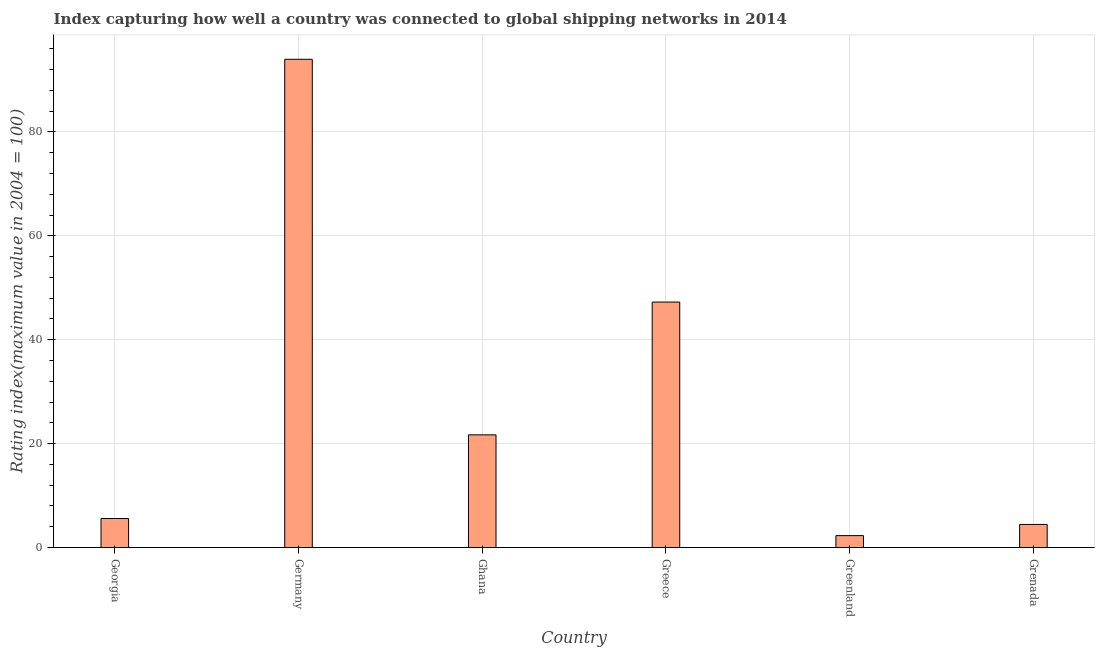Does the graph contain any zero values?
Make the answer very short. No. What is the title of the graph?
Keep it short and to the point. Index capturing how well a country was connected to global shipping networks in 2014. What is the label or title of the X-axis?
Provide a succinct answer. Country. What is the label or title of the Y-axis?
Make the answer very short. Rating index(maximum value in 2004 = 100). What is the liner shipping connectivity index in Germany?
Your response must be concise. 93.98. Across all countries, what is the maximum liner shipping connectivity index?
Provide a succinct answer. 93.98. Across all countries, what is the minimum liner shipping connectivity index?
Give a very brief answer. 2.3. In which country was the liner shipping connectivity index minimum?
Provide a succinct answer. Greenland. What is the sum of the liner shipping connectivity index?
Offer a terse response. 175.24. What is the difference between the liner shipping connectivity index in Greenland and Grenada?
Make the answer very short. -2.15. What is the average liner shipping connectivity index per country?
Keep it short and to the point. 29.21. What is the median liner shipping connectivity index?
Your answer should be very brief. 13.64. What is the ratio of the liner shipping connectivity index in Germany to that in Grenada?
Give a very brief answer. 21.12. Is the liner shipping connectivity index in Ghana less than that in Greece?
Your answer should be compact. Yes. Is the difference between the liner shipping connectivity index in Ghana and Greenland greater than the difference between any two countries?
Keep it short and to the point. No. What is the difference between the highest and the second highest liner shipping connectivity index?
Ensure brevity in your answer.  46.73. Is the sum of the liner shipping connectivity index in Georgia and Ghana greater than the maximum liner shipping connectivity index across all countries?
Ensure brevity in your answer.  No. What is the difference between the highest and the lowest liner shipping connectivity index?
Your answer should be very brief. 91.68. Are all the bars in the graph horizontal?
Your answer should be very brief. No. What is the difference between two consecutive major ticks on the Y-axis?
Give a very brief answer. 20. Are the values on the major ticks of Y-axis written in scientific E-notation?
Provide a succinct answer. No. What is the Rating index(maximum value in 2004 = 100) in Georgia?
Your answer should be very brief. 5.58. What is the Rating index(maximum value in 2004 = 100) of Germany?
Give a very brief answer. 93.98. What is the Rating index(maximum value in 2004 = 100) in Ghana?
Keep it short and to the point. 21.69. What is the Rating index(maximum value in 2004 = 100) of Greece?
Offer a very short reply. 47.25. What is the Rating index(maximum value in 2004 = 100) of Greenland?
Provide a short and direct response. 2.3. What is the Rating index(maximum value in 2004 = 100) in Grenada?
Ensure brevity in your answer.  4.45. What is the difference between the Rating index(maximum value in 2004 = 100) in Georgia and Germany?
Keep it short and to the point. -88.39. What is the difference between the Rating index(maximum value in 2004 = 100) in Georgia and Ghana?
Provide a succinct answer. -16.11. What is the difference between the Rating index(maximum value in 2004 = 100) in Georgia and Greece?
Your response must be concise. -41.66. What is the difference between the Rating index(maximum value in 2004 = 100) in Georgia and Greenland?
Give a very brief answer. 3.29. What is the difference between the Rating index(maximum value in 2004 = 100) in Georgia and Grenada?
Ensure brevity in your answer.  1.13. What is the difference between the Rating index(maximum value in 2004 = 100) in Germany and Ghana?
Your response must be concise. 72.29. What is the difference between the Rating index(maximum value in 2004 = 100) in Germany and Greece?
Keep it short and to the point. 46.73. What is the difference between the Rating index(maximum value in 2004 = 100) in Germany and Greenland?
Offer a very short reply. 91.68. What is the difference between the Rating index(maximum value in 2004 = 100) in Germany and Grenada?
Offer a terse response. 89.52. What is the difference between the Rating index(maximum value in 2004 = 100) in Ghana and Greece?
Give a very brief answer. -25.56. What is the difference between the Rating index(maximum value in 2004 = 100) in Ghana and Greenland?
Offer a very short reply. 19.39. What is the difference between the Rating index(maximum value in 2004 = 100) in Ghana and Grenada?
Your response must be concise. 17.24. What is the difference between the Rating index(maximum value in 2004 = 100) in Greece and Greenland?
Your answer should be compact. 44.95. What is the difference between the Rating index(maximum value in 2004 = 100) in Greece and Grenada?
Give a very brief answer. 42.8. What is the difference between the Rating index(maximum value in 2004 = 100) in Greenland and Grenada?
Offer a very short reply. -2.15. What is the ratio of the Rating index(maximum value in 2004 = 100) in Georgia to that in Germany?
Provide a succinct answer. 0.06. What is the ratio of the Rating index(maximum value in 2004 = 100) in Georgia to that in Ghana?
Offer a terse response. 0.26. What is the ratio of the Rating index(maximum value in 2004 = 100) in Georgia to that in Greece?
Your answer should be compact. 0.12. What is the ratio of the Rating index(maximum value in 2004 = 100) in Georgia to that in Greenland?
Provide a succinct answer. 2.43. What is the ratio of the Rating index(maximum value in 2004 = 100) in Georgia to that in Grenada?
Offer a very short reply. 1.25. What is the ratio of the Rating index(maximum value in 2004 = 100) in Germany to that in Ghana?
Make the answer very short. 4.33. What is the ratio of the Rating index(maximum value in 2004 = 100) in Germany to that in Greece?
Provide a short and direct response. 1.99. What is the ratio of the Rating index(maximum value in 2004 = 100) in Germany to that in Greenland?
Keep it short and to the point. 40.94. What is the ratio of the Rating index(maximum value in 2004 = 100) in Germany to that in Grenada?
Your response must be concise. 21.12. What is the ratio of the Rating index(maximum value in 2004 = 100) in Ghana to that in Greece?
Provide a short and direct response. 0.46. What is the ratio of the Rating index(maximum value in 2004 = 100) in Ghana to that in Greenland?
Your response must be concise. 9.45. What is the ratio of the Rating index(maximum value in 2004 = 100) in Ghana to that in Grenada?
Your answer should be compact. 4.87. What is the ratio of the Rating index(maximum value in 2004 = 100) in Greece to that in Greenland?
Your response must be concise. 20.58. What is the ratio of the Rating index(maximum value in 2004 = 100) in Greece to that in Grenada?
Your answer should be compact. 10.62. What is the ratio of the Rating index(maximum value in 2004 = 100) in Greenland to that in Grenada?
Ensure brevity in your answer.  0.52. 